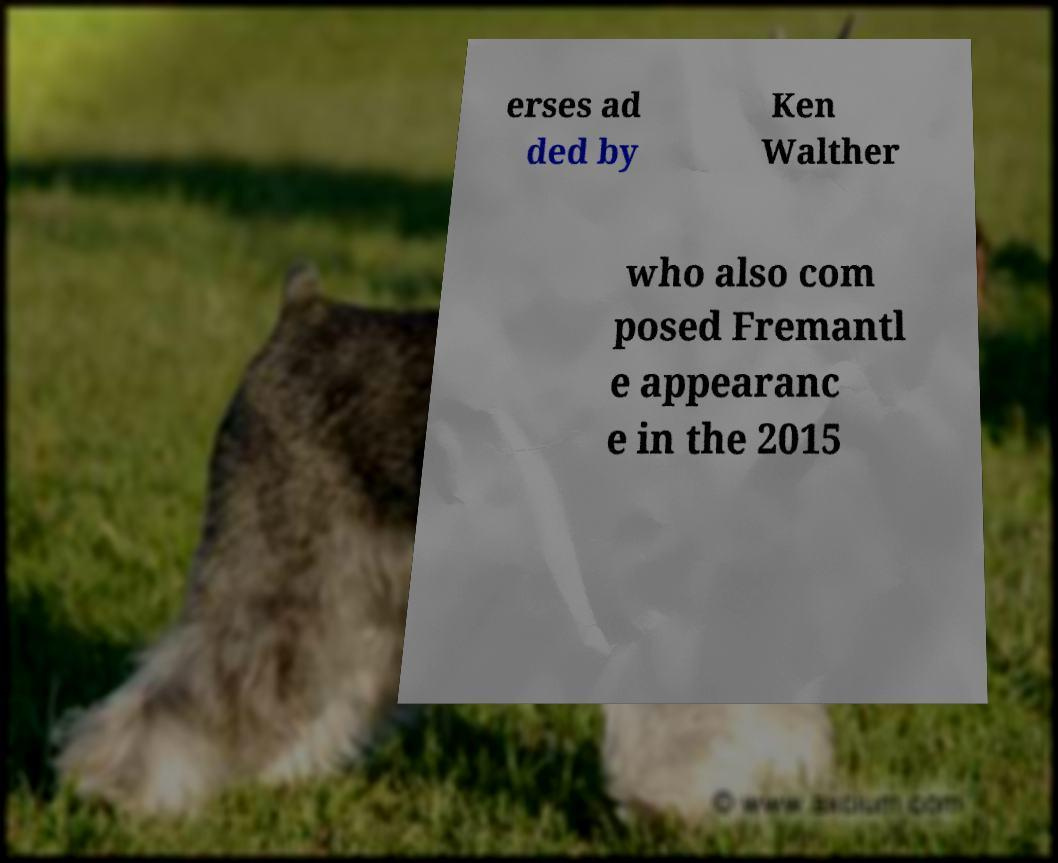Please identify and transcribe the text found in this image. erses ad ded by Ken Walther who also com posed Fremantl e appearanc e in the 2015 